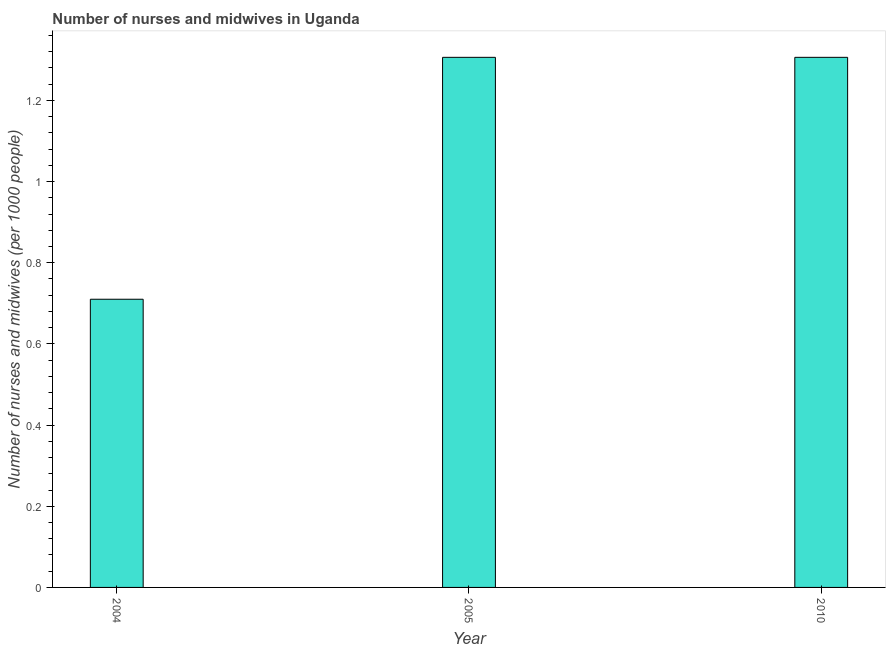Does the graph contain any zero values?
Keep it short and to the point. No. Does the graph contain grids?
Ensure brevity in your answer.  No. What is the title of the graph?
Make the answer very short. Number of nurses and midwives in Uganda. What is the label or title of the X-axis?
Your answer should be compact. Year. What is the label or title of the Y-axis?
Ensure brevity in your answer.  Number of nurses and midwives (per 1000 people). What is the number of nurses and midwives in 2005?
Offer a terse response. 1.31. Across all years, what is the maximum number of nurses and midwives?
Your answer should be compact. 1.31. Across all years, what is the minimum number of nurses and midwives?
Ensure brevity in your answer.  0.71. What is the sum of the number of nurses and midwives?
Keep it short and to the point. 3.32. What is the difference between the number of nurses and midwives in 2004 and 2010?
Your response must be concise. -0.6. What is the average number of nurses and midwives per year?
Keep it short and to the point. 1.11. What is the median number of nurses and midwives?
Keep it short and to the point. 1.31. In how many years, is the number of nurses and midwives greater than 0.52 ?
Offer a very short reply. 3. What is the ratio of the number of nurses and midwives in 2004 to that in 2010?
Make the answer very short. 0.54. How many bars are there?
Keep it short and to the point. 3. What is the difference between two consecutive major ticks on the Y-axis?
Make the answer very short. 0.2. What is the Number of nurses and midwives (per 1000 people) of 2004?
Your answer should be very brief. 0.71. What is the Number of nurses and midwives (per 1000 people) of 2005?
Offer a very short reply. 1.31. What is the Number of nurses and midwives (per 1000 people) of 2010?
Offer a terse response. 1.31. What is the difference between the Number of nurses and midwives (per 1000 people) in 2004 and 2005?
Provide a succinct answer. -0.6. What is the difference between the Number of nurses and midwives (per 1000 people) in 2004 and 2010?
Offer a very short reply. -0.6. What is the ratio of the Number of nurses and midwives (per 1000 people) in 2004 to that in 2005?
Your answer should be very brief. 0.54. What is the ratio of the Number of nurses and midwives (per 1000 people) in 2004 to that in 2010?
Provide a short and direct response. 0.54. 